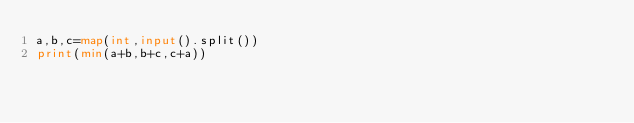Convert code to text. <code><loc_0><loc_0><loc_500><loc_500><_Python_>a,b,c=map(int,input().split())
print(min(a+b,b+c,c+a))</code> 